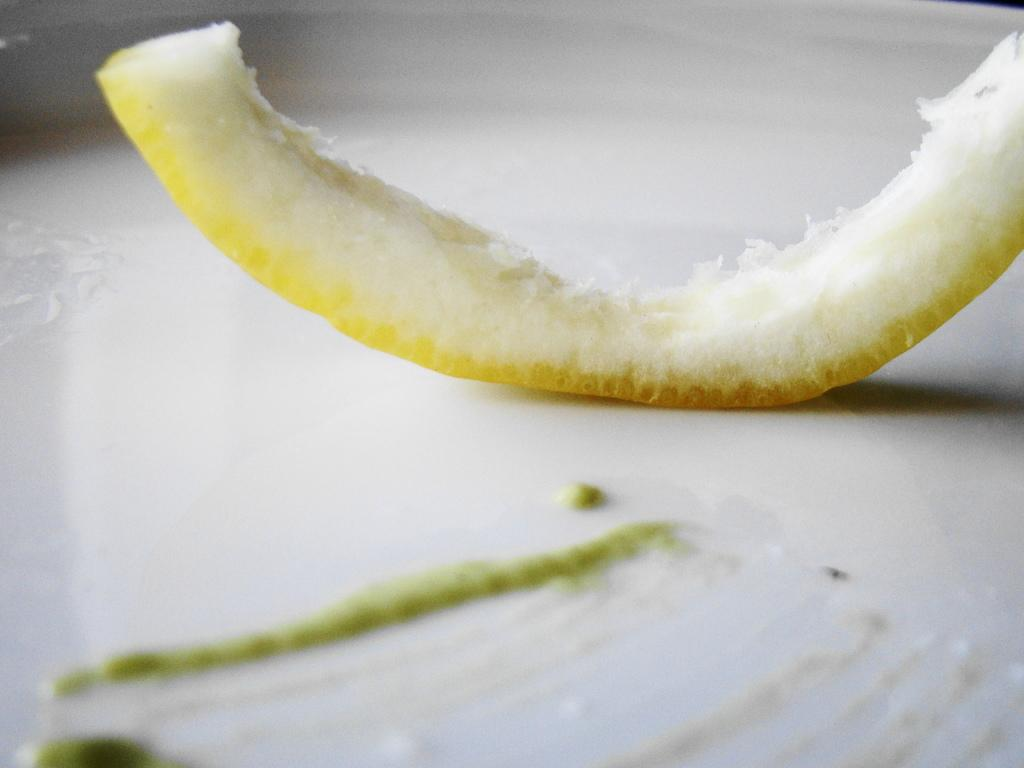What is the main subject of the image? The main subject of the image is a melon ring. Where is the melon ring located in the image? The melon ring is placed in a plate. What type of chain is holding the pig in the image? There is no pig or chain present in the image; it only features a melon ring in a plate. 